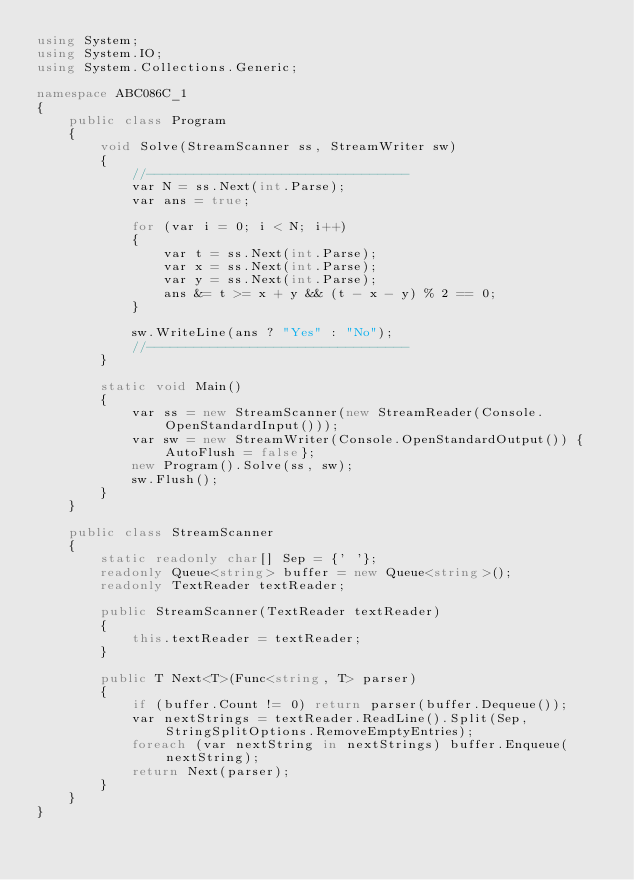Convert code to text. <code><loc_0><loc_0><loc_500><loc_500><_C#_>using System;
using System.IO;
using System.Collections.Generic;

namespace ABC086C_1
{
    public class Program
    {
        void Solve(StreamScanner ss, StreamWriter sw)
        {
            //---------------------------------
            var N = ss.Next(int.Parse);
            var ans = true;

            for (var i = 0; i < N; i++)
            {
                var t = ss.Next(int.Parse);
                var x = ss.Next(int.Parse);
                var y = ss.Next(int.Parse);
                ans &= t >= x + y && (t - x - y) % 2 == 0;
            }

            sw.WriteLine(ans ? "Yes" : "No");
            //---------------------------------
        }

        static void Main()
        {
            var ss = new StreamScanner(new StreamReader(Console.OpenStandardInput()));
            var sw = new StreamWriter(Console.OpenStandardOutput()) {AutoFlush = false};
            new Program().Solve(ss, sw);
            sw.Flush();
        }
    }

    public class StreamScanner
    {
        static readonly char[] Sep = {' '};
        readonly Queue<string> buffer = new Queue<string>();
        readonly TextReader textReader;

        public StreamScanner(TextReader textReader)
        {
            this.textReader = textReader;
        }

        public T Next<T>(Func<string, T> parser)
        {
            if (buffer.Count != 0) return parser(buffer.Dequeue());
            var nextStrings = textReader.ReadLine().Split(Sep, StringSplitOptions.RemoveEmptyEntries);
            foreach (var nextString in nextStrings) buffer.Enqueue(nextString);
            return Next(parser);
        }
    }
}
</code> 